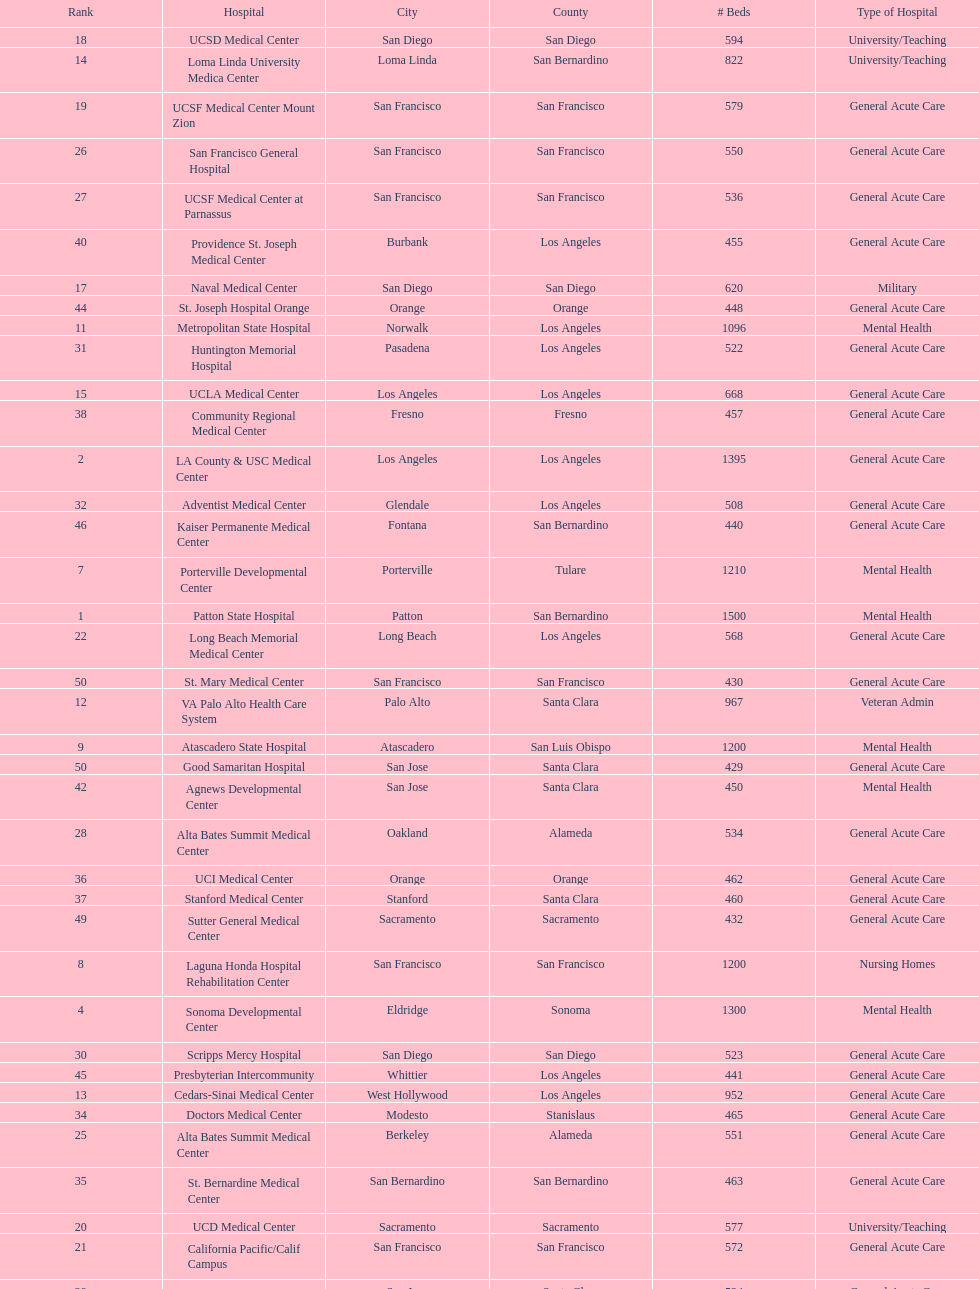Does patton state hospital in the city of patton in san bernardino county have more mental health hospital beds than atascadero state hospital in atascadero, san luis obispo county? Yes. 